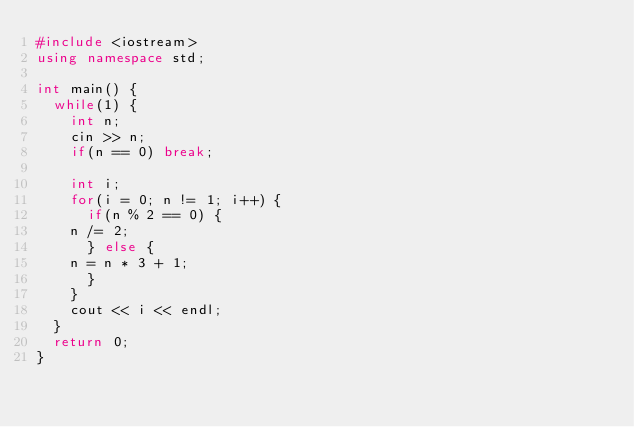<code> <loc_0><loc_0><loc_500><loc_500><_C++_>#include <iostream>
using namespace std;

int main() {
  while(1) {
    int n;
    cin >> n;
    if(n == 0) break;

    int i;
    for(i = 0; n != 1; i++) {
      if(n % 2 == 0) {
	n /= 2;
      } else {
	n = n * 3 + 1;
      }
    }
    cout << i << endl;
  }
  return 0;
}</code> 